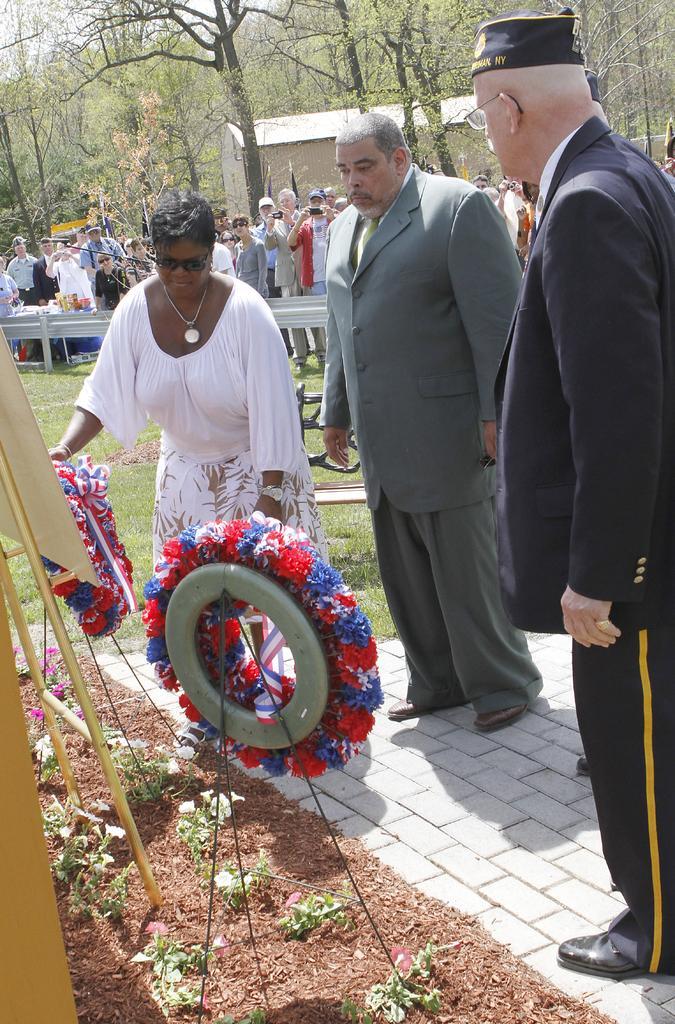Can you describe this image briefly? In this image in the foreground there are three peoples, garland,rope, plants , flowers visible, in the middle there is a fence, in front of fence there are few peoples standing, some of them holding mobiles taking the picture, there is bicycle wheel visible on the ground in the middle, at the top there are some trees,house visible. 